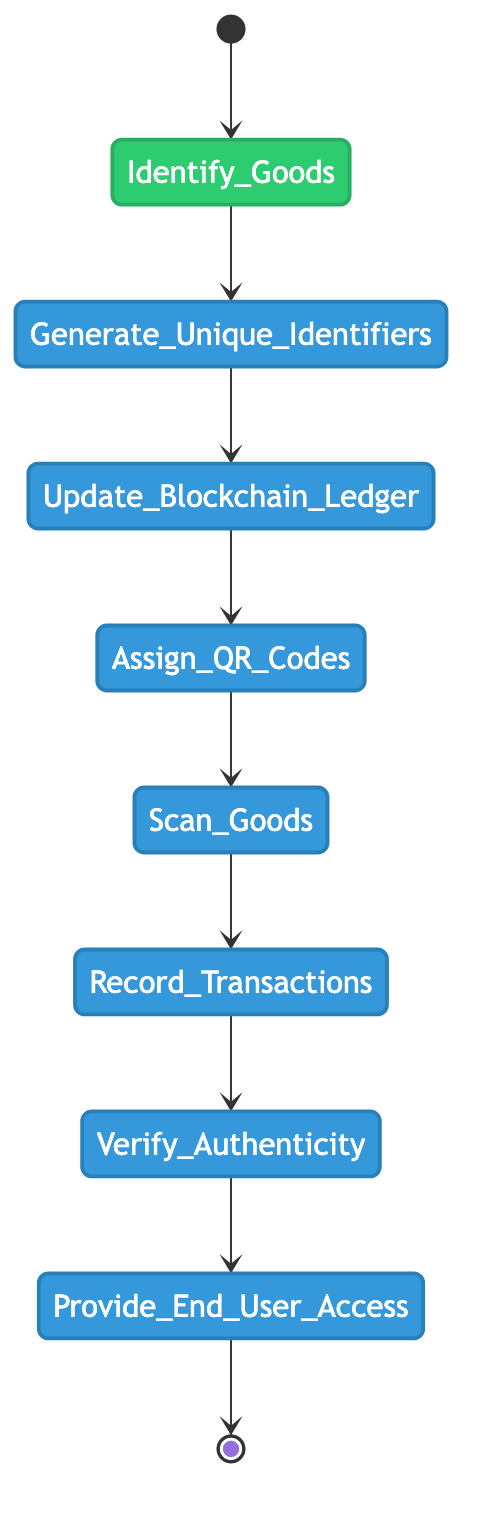What is the first activity in the process? The first activity in the diagram is represented by the start point, which transitions to the "Identify Goods for Tracking" activity.
Answer: Identify Goods for Tracking How many activities are there in total in the diagram? Counting all the activities in the diagram, starting from "Identify Goods for Tracking" to "Provide End-User Access to Product History," we find that there are 8 activities in total.
Answer: 8 What activity comes immediately after generating unique identifiers? Following the "Generate Unique Blockchain Identifiers" activity, the next activity in the flow is "Update Blockchain Ledger with Goods Information."
Answer: Update Blockchain Ledger with Goods Information Which activity precedes the transaction recording? The activity that comes before "Record Transactions on Blockchain" is "Scan QR Codes at Key Checkpoints," establishing a prerequisite action for recording transactions.
Answer: Scan QR Codes at Key Checkpoints What is the last activity before the process ends? The final activity before reaching the end of the process is "Provide End-User Access to Product History," marking the last step in the flow.
Answer: Provide End-User Access to Product History How are QR codes used in the process? QR codes are assigned to goods in the "Assign QR Codes to Goods" activity, which allows them to be scanned at key checkpoints later in the process.
Answer: Assign QR Codes to Goods How many transitions are there from the "scan goods" activity? There is one transition originating from the "Scan QR Codes at Key Checkpoints" activity, leading directly to the "Record Transactions on Blockchain."
Answer: 1 Which activity involves verifying the authenticity of goods? The diagram represents the "Verify Authenticity of Goods" as the specific activity that engages in the verification process for goods within the blockchain system.
Answer: Verify Authenticity of Goods What follows after verifying authenticity in the workflow? After "Verify Authenticity of Goods," the subsequent activity is "Provide End-User Access to Product History," indicating the process of making information available to consumers.
Answer: Provide End-User Access to Product History 